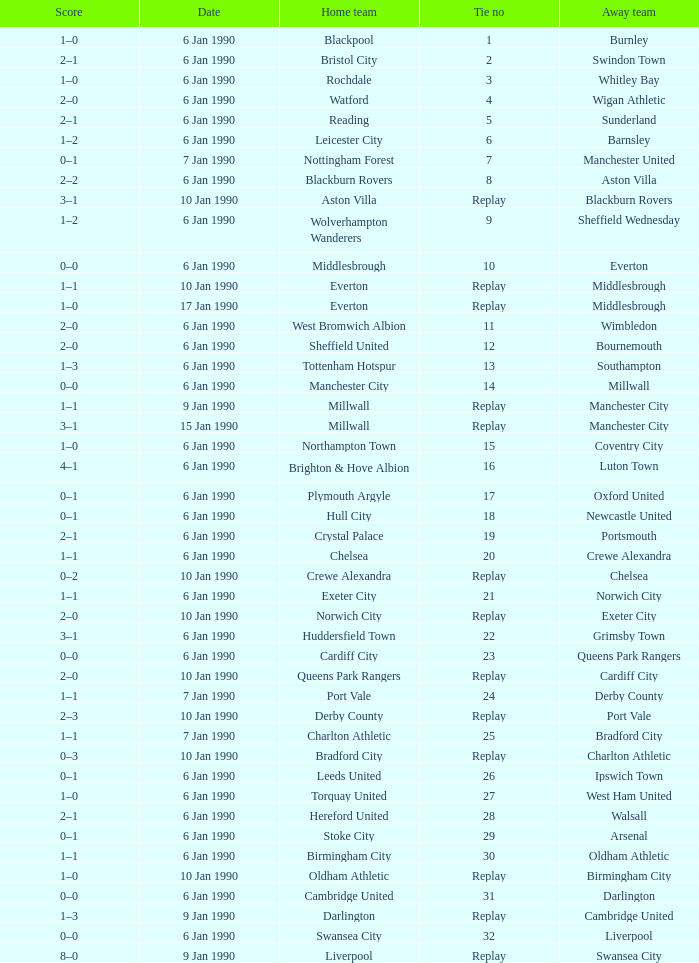Would you be able to parse every entry in this table? {'header': ['Score', 'Date', 'Home team', 'Tie no', 'Away team'], 'rows': [['1–0', '6 Jan 1990', 'Blackpool', '1', 'Burnley'], ['2–1', '6 Jan 1990', 'Bristol City', '2', 'Swindon Town'], ['1–0', '6 Jan 1990', 'Rochdale', '3', 'Whitley Bay'], ['2–0', '6 Jan 1990', 'Watford', '4', 'Wigan Athletic'], ['2–1', '6 Jan 1990', 'Reading', '5', 'Sunderland'], ['1–2', '6 Jan 1990', 'Leicester City', '6', 'Barnsley'], ['0–1', '7 Jan 1990', 'Nottingham Forest', '7', 'Manchester United'], ['2–2', '6 Jan 1990', 'Blackburn Rovers', '8', 'Aston Villa'], ['3–1', '10 Jan 1990', 'Aston Villa', 'Replay', 'Blackburn Rovers'], ['1–2', '6 Jan 1990', 'Wolverhampton Wanderers', '9', 'Sheffield Wednesday'], ['0–0', '6 Jan 1990', 'Middlesbrough', '10', 'Everton'], ['1–1', '10 Jan 1990', 'Everton', 'Replay', 'Middlesbrough'], ['1–0', '17 Jan 1990', 'Everton', 'Replay', 'Middlesbrough'], ['2–0', '6 Jan 1990', 'West Bromwich Albion', '11', 'Wimbledon'], ['2–0', '6 Jan 1990', 'Sheffield United', '12', 'Bournemouth'], ['1–3', '6 Jan 1990', 'Tottenham Hotspur', '13', 'Southampton'], ['0–0', '6 Jan 1990', 'Manchester City', '14', 'Millwall'], ['1–1', '9 Jan 1990', 'Millwall', 'Replay', 'Manchester City'], ['3–1', '15 Jan 1990', 'Millwall', 'Replay', 'Manchester City'], ['1–0', '6 Jan 1990', 'Northampton Town', '15', 'Coventry City'], ['4–1', '6 Jan 1990', 'Brighton & Hove Albion', '16', 'Luton Town'], ['0–1', '6 Jan 1990', 'Plymouth Argyle', '17', 'Oxford United'], ['0–1', '6 Jan 1990', 'Hull City', '18', 'Newcastle United'], ['2–1', '6 Jan 1990', 'Crystal Palace', '19', 'Portsmouth'], ['1–1', '6 Jan 1990', 'Chelsea', '20', 'Crewe Alexandra'], ['0–2', '10 Jan 1990', 'Crewe Alexandra', 'Replay', 'Chelsea'], ['1–1', '6 Jan 1990', 'Exeter City', '21', 'Norwich City'], ['2–0', '10 Jan 1990', 'Norwich City', 'Replay', 'Exeter City'], ['3–1', '6 Jan 1990', 'Huddersfield Town', '22', 'Grimsby Town'], ['0–0', '6 Jan 1990', 'Cardiff City', '23', 'Queens Park Rangers'], ['2–0', '10 Jan 1990', 'Queens Park Rangers', 'Replay', 'Cardiff City'], ['1–1', '7 Jan 1990', 'Port Vale', '24', 'Derby County'], ['2–3', '10 Jan 1990', 'Derby County', 'Replay', 'Port Vale'], ['1–1', '7 Jan 1990', 'Charlton Athletic', '25', 'Bradford City'], ['0–3', '10 Jan 1990', 'Bradford City', 'Replay', 'Charlton Athletic'], ['0–1', '6 Jan 1990', 'Leeds United', '26', 'Ipswich Town'], ['1–0', '6 Jan 1990', 'Torquay United', '27', 'West Ham United'], ['2–1', '6 Jan 1990', 'Hereford United', '28', 'Walsall'], ['0–1', '6 Jan 1990', 'Stoke City', '29', 'Arsenal'], ['1–1', '6 Jan 1990', 'Birmingham City', '30', 'Oldham Athletic'], ['1–0', '10 Jan 1990', 'Oldham Athletic', 'Replay', 'Birmingham City'], ['0–0', '6 Jan 1990', 'Cambridge United', '31', 'Darlington'], ['1–3', '9 Jan 1990', 'Darlington', 'Replay', 'Cambridge United'], ['0–0', '6 Jan 1990', 'Swansea City', '32', 'Liverpool'], ['8–0', '9 Jan 1990', 'Liverpool', 'Replay', 'Swansea City']]} What is the tie no of the game where exeter city was the home team? 21.0. 